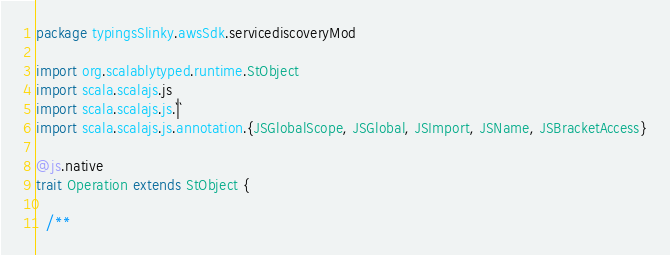Convert code to text. <code><loc_0><loc_0><loc_500><loc_500><_Scala_>package typingsSlinky.awsSdk.servicediscoveryMod

import org.scalablytyped.runtime.StObject
import scala.scalajs.js
import scala.scalajs.js.`|`
import scala.scalajs.js.annotation.{JSGlobalScope, JSGlobal, JSImport, JSName, JSBracketAccess}

@js.native
trait Operation extends StObject {
  
  /**</code> 